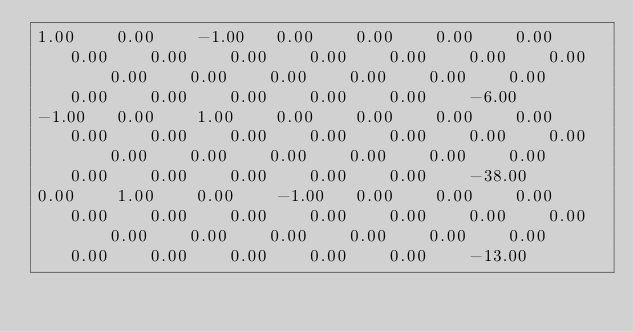<code> <loc_0><loc_0><loc_500><loc_500><_Matlab_>1.00	0.00	-1.00	0.00	0.00	0.00	0.00	0.00	0.00	0.00	0.00	0.00	0.00	0.00	0.00	0.00	0.00	0.00	0.00	0.00	0.00	0.00	0.00	0.00	0.00	-6.00
-1.00	0.00	1.00	0.00	0.00	0.00	0.00	0.00	0.00	0.00	0.00	0.00	0.00	0.00	0.00	0.00	0.00	0.00	0.00	0.00	0.00	0.00	0.00	0.00	0.00	-38.00
0.00	1.00	0.00	-1.00	0.00	0.00	0.00	0.00	0.00	0.00	0.00	0.00	0.00	0.00	0.00	0.00	0.00	0.00	0.00	0.00	0.00	0.00	0.00	0.00	0.00	-13.00</code> 